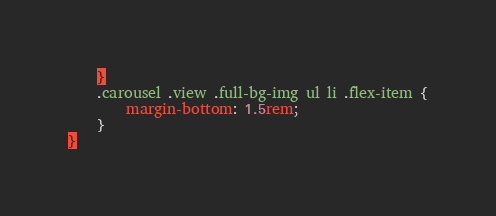<code> <loc_0><loc_0><loc_500><loc_500><_CSS_>    }
    .carousel .view .full-bg-img ul li .flex-item {
        margin-bottom: 1.5rem;
    }
}</code> 